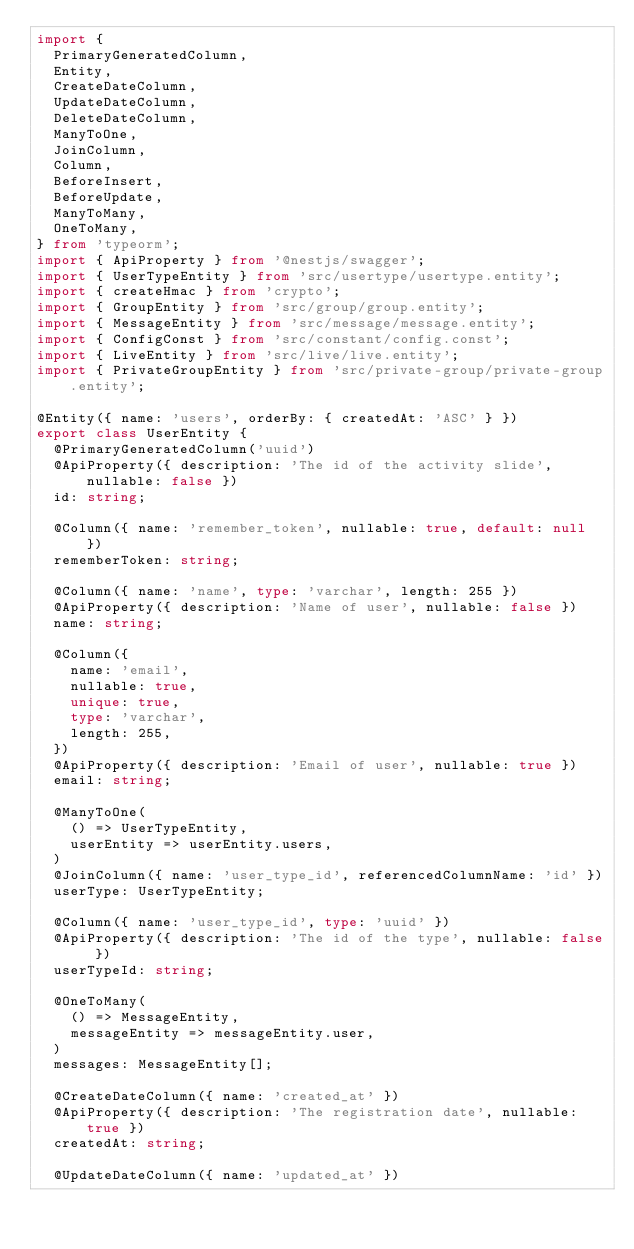Convert code to text. <code><loc_0><loc_0><loc_500><loc_500><_TypeScript_>import {
  PrimaryGeneratedColumn,
  Entity,
  CreateDateColumn,
  UpdateDateColumn,
  DeleteDateColumn,
  ManyToOne,
  JoinColumn,
  Column,
  BeforeInsert,
  BeforeUpdate,
  ManyToMany,
  OneToMany,
} from 'typeorm';
import { ApiProperty } from '@nestjs/swagger';
import { UserTypeEntity } from 'src/usertype/usertype.entity';
import { createHmac } from 'crypto';
import { GroupEntity } from 'src/group/group.entity';
import { MessageEntity } from 'src/message/message.entity';
import { ConfigConst } from 'src/constant/config.const';
import { LiveEntity } from 'src/live/live.entity';
import { PrivateGroupEntity } from 'src/private-group/private-group.entity';

@Entity({ name: 'users', orderBy: { createdAt: 'ASC' } })
export class UserEntity {
  @PrimaryGeneratedColumn('uuid')
  @ApiProperty({ description: 'The id of the activity slide', nullable: false })
  id: string;

  @Column({ name: 'remember_token', nullable: true, default: null })
  rememberToken: string;

  @Column({ name: 'name', type: 'varchar', length: 255 })
  @ApiProperty({ description: 'Name of user', nullable: false })
  name: string;

  @Column({
    name: 'email',
    nullable: true,
    unique: true,
    type: 'varchar',
    length: 255,
  })
  @ApiProperty({ description: 'Email of user', nullable: true })
  email: string;

  @ManyToOne(
    () => UserTypeEntity,
    userEntity => userEntity.users,
  )
  @JoinColumn({ name: 'user_type_id', referencedColumnName: 'id' })
  userType: UserTypeEntity;

  @Column({ name: 'user_type_id', type: 'uuid' })
  @ApiProperty({ description: 'The id of the type', nullable: false })
  userTypeId: string;

  @OneToMany(
    () => MessageEntity,
    messageEntity => messageEntity.user,
  )
  messages: MessageEntity[];

  @CreateDateColumn({ name: 'created_at' })
  @ApiProperty({ description: 'The registration date', nullable: true })
  createdAt: string;

  @UpdateDateColumn({ name: 'updated_at' })</code> 